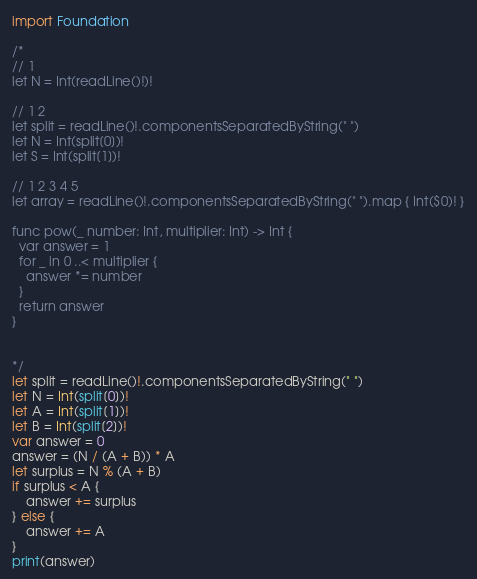Convert code to text. <code><loc_0><loc_0><loc_500><loc_500><_Swift_>import Foundation

/*
// 1
let N = Int(readLine()!)!

// 1 2
let split = readLine()!.componentsSeparatedByString(" ")
let N = Int(split[0])!
let S = Int(split[1])!

// 1 2 3 4 5
let array = readLine()!.componentsSeparatedByString(" ").map { Int($0)! }

func pow(_ number: Int, multiplier: Int) -> Int {
  var answer = 1
  for _ in 0 ..< multiplier {
    answer *= number 
  }
  return answer
}


*/
let split = readLine()!.componentsSeparatedByString(" ")
let N = Int(split[0])!
let A = Int(split[1])!
let B = Int(split[2])!
var answer = 0
answer = (N / (A + B)) * A
let surplus = N % (A + B)
if surplus < A {
	answer += surplus
} else {
 	answer += A 
}
print(answer)</code> 